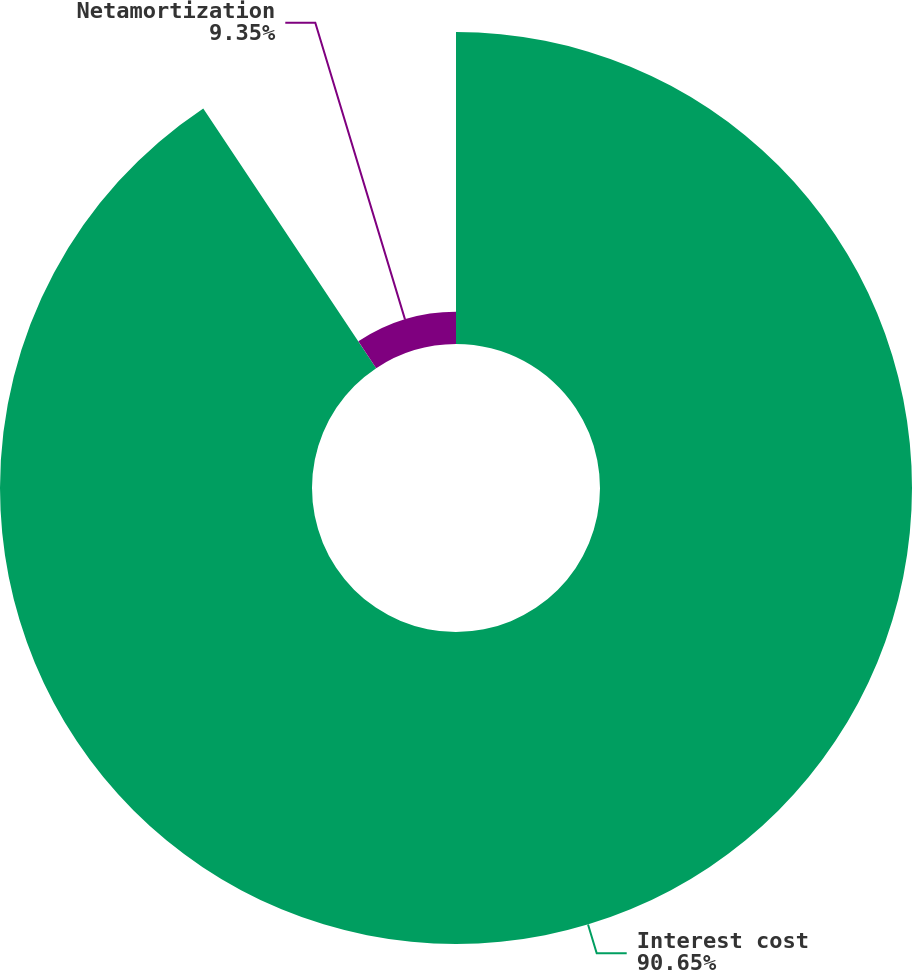Convert chart. <chart><loc_0><loc_0><loc_500><loc_500><pie_chart><fcel>Interest cost<fcel>Netamortization<nl><fcel>90.65%<fcel>9.35%<nl></chart> 